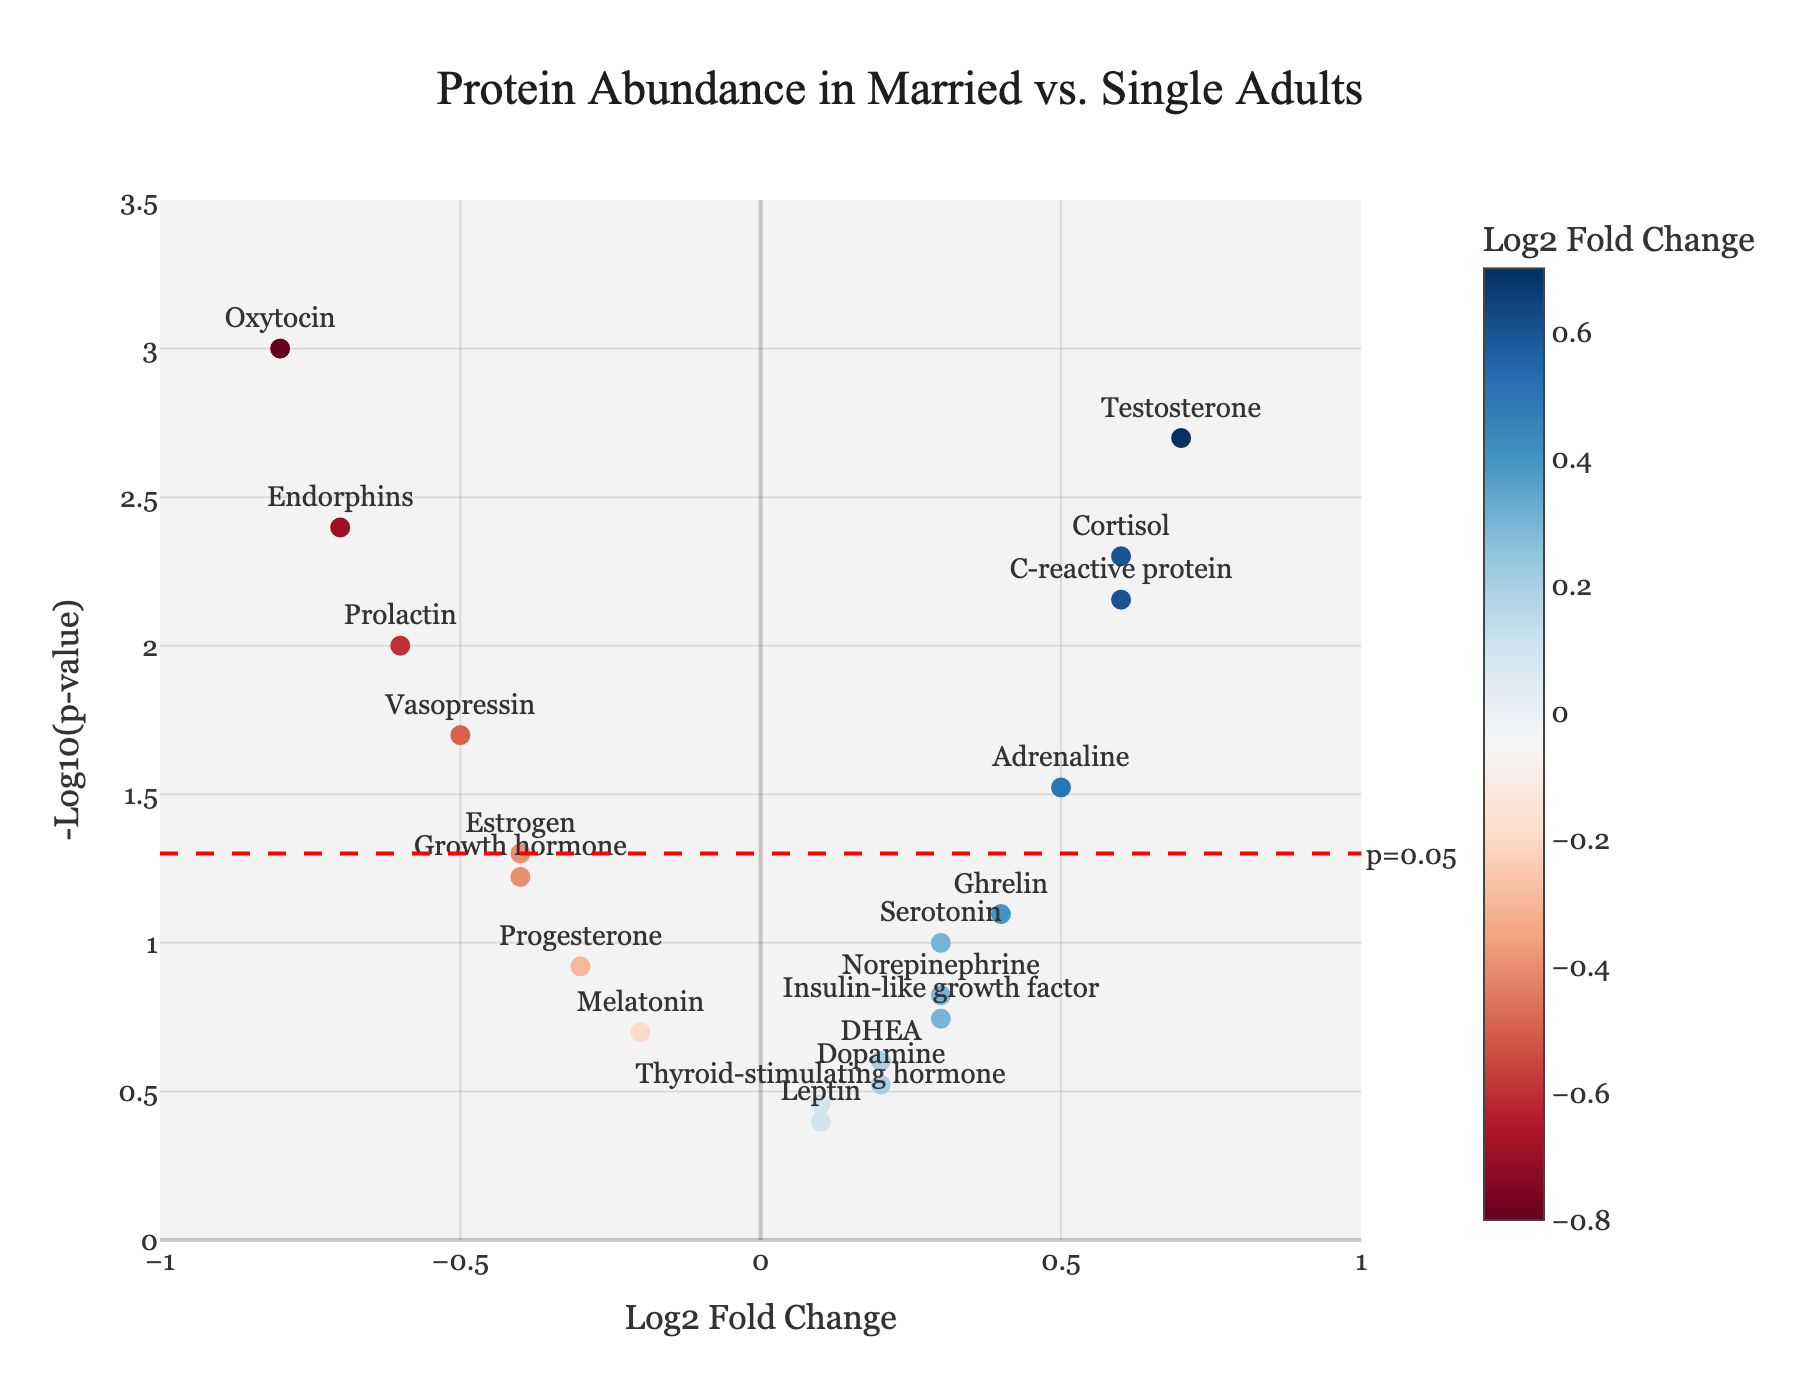What's the title of the figure? The title of the figure is located at the top and reads "Protein Abundance in Married vs. Single Adults".
Answer: "Protein Abundance in Married vs. Single Adults" How many proteins have a log2 fold change greater than 0.5? To determine this, we count the number of data points where the 'log2FoldChange' is greater than 0.5.
Answer: 4 Which protein has the highest -log10(p-value)? By looking at the y-axis values, which represent -log10(p-value), and identifying the protein with the highest value, we find that Oxytocin is at the top.
Answer: Oxytocin What is the p-value significance threshold indicated by the horizontal line? The horizontal line is labeled with "p=0.05", indicating that it's the threshold for significance, and it's at -log10(0.05).
Answer: 0.05 Which proteins are significantly different according to the p-value significance threshold? Proteins above the significance threshold line (y = 1.3) have p-values less than 0.05. These include Oxytocin, Testosterone, Endorphins, Prolactin, Cortisol, Adrenaline, and C-reactive protein.
Answer: Oxytocin, Testosterone, Endorphins, Prolactin, Cortisol, Adrenaline, C-reactive protein Are there more proteins with increased abundance or decreased abundance in married adults compared to single adults? To determine this, count the number of data points with positive log2 fold change (increased abundance) versus those with negative log2 fold change (decreased abundance). There are 8 proteins with increased abundance and 11 with decreased abundance.
Answer: Decreased abundance Which protein shows the greatest decrease in abundance? The greatest decrease in abundance is represented by the most negative log2 fold change, which is Oxytocin with a log2FoldChange of -0.8.
Answer: Oxytocin Compare the significance of Testosterone and Prolactin. Which one has a lower p-value? The p-values for Testosterone and Prolactin can be compared by looking at their -log10(p-value) values. Testosterone (0.7, -log10(0.002)) has a higher -log10(p-value) than Prolactin (-0.6, -log10(0.01)), meaning it has a lower p-value.
Answer: Testosterone Which protein shows the smallest log2 fold change? The protein with the log2 fold change closest to 0 can be identified from the x-axis values. Leptin shows the smallest change with a log2FoldChange of 0.1.
Answer: Leptin How does the abundance of Serotonin compare with that of Endorphins? Serotonin has a higher log2 fold change (0.3) compared to Endorphins (-0.7), indicating that Serotonin is more abundant in married adults relative to Endorphins.
Answer: Serotonin is more abundant 